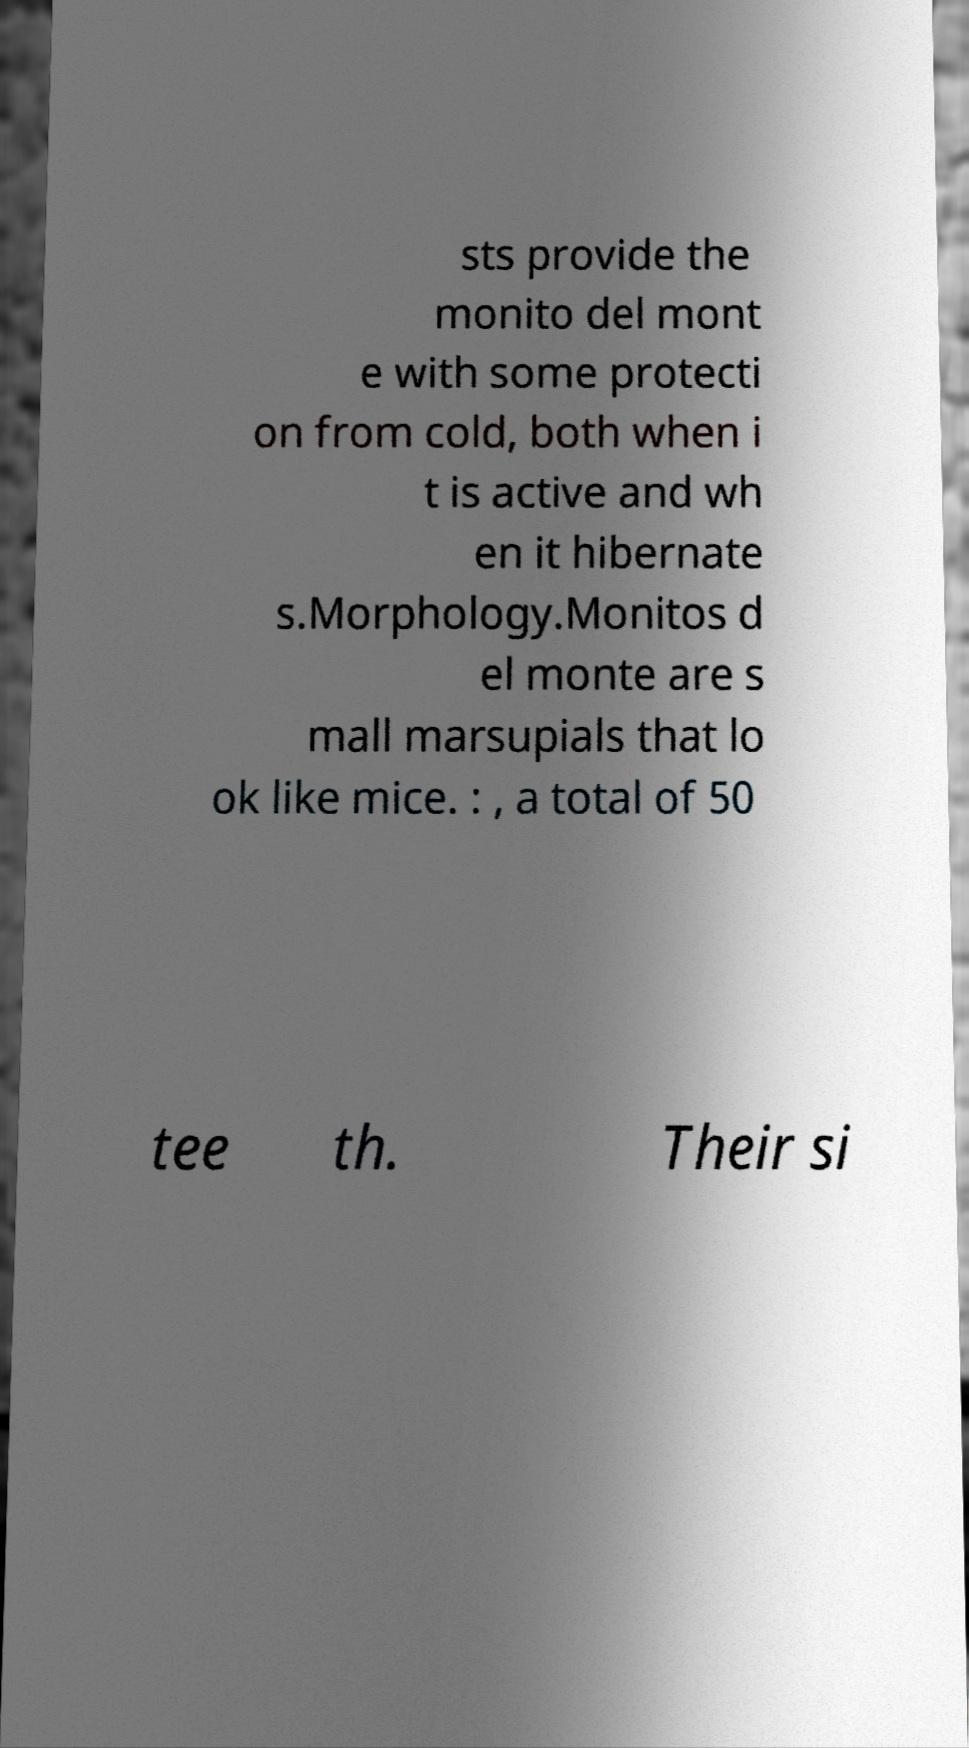Please read and relay the text visible in this image. What does it say? sts provide the monito del mont e with some protecti on from cold, both when i t is active and wh en it hibernate s.Morphology.Monitos d el monte are s mall marsupials that lo ok like mice. : , a total of 50 tee th. Their si 